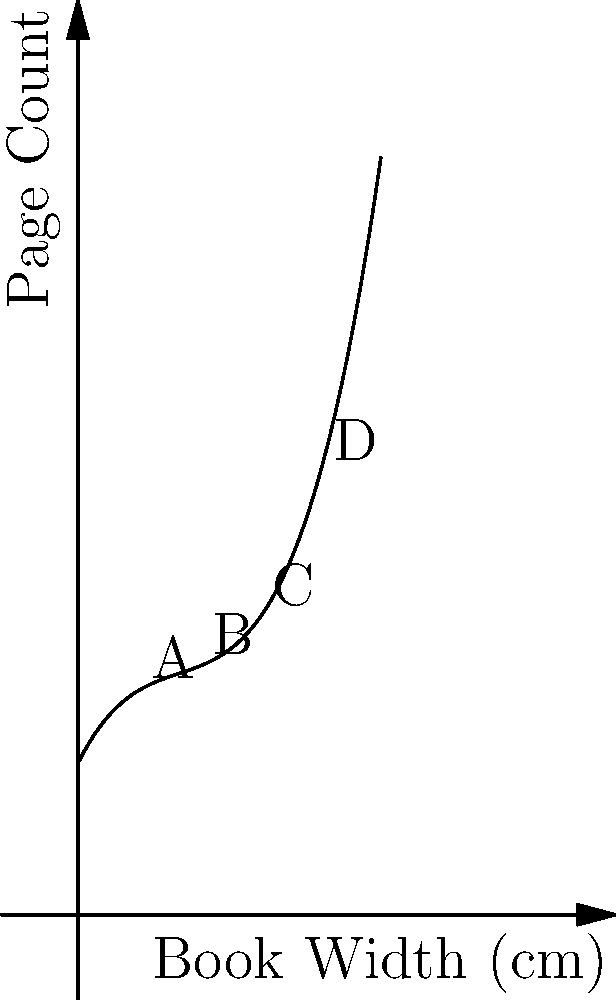Consider the graph depicting the relationship between book width and page count for a collection of Renaissance literature. The curve is modeled by the function $f(x) = 0.0005x^3 - 0.05x^2 + 2x + 50$, where $x$ represents the book width in centimeters and $f(x)$ represents the page count. Which point on the curve most likely represents a typical quarto edition, known for its moderate size and readability? To determine which point best represents a typical quarto edition, we need to consider the characteristics of quarto books in Renaissance literature:

1. Quarto editions were moderately sized, typically smaller than folios but larger than octavos.
2. They were popular for their balance between readability and portability.

Analyzing the given points:

A: Located at approximately (20, 90)
B: Located at approximately (40, 130)
C: Located at approximately (60, 170)
D: Located at approximately (80, 250)

Step 1: Eliminate extremes
- Point A is likely too small for a quarto, possibly representing an octavo.
- Point D is too large, more likely representing a folio edition.

Step 2: Compare remaining options
Between B and C, B represents a more moderate size, which aligns better with the typical quarto characteristics.

Step 3: Verify with historical context
Quarto editions in the Renaissance typically had dimensions around 9-12 inches (23-30 cm) in height. The width would be proportionally smaller, making 40 cm a reasonable estimate for the open width of a quarto book.

Step 4: Consider page count
The page count of about 130 for point B is reasonable for a quarto edition of Renaissance literature, which often contained plays or moderate-length works.

Therefore, point B most likely represents a typical quarto edition, balancing size and readability.
Answer: B 